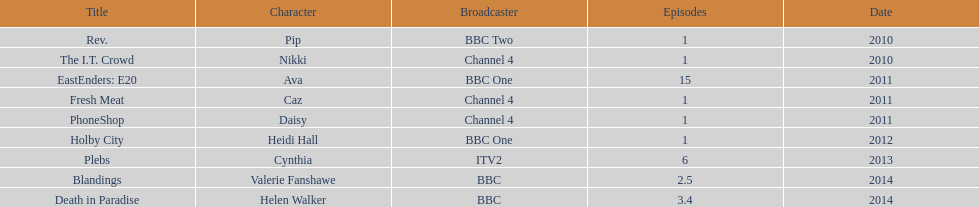What is the entire sum of shows with appearances by sophie colguhoun? 9. 